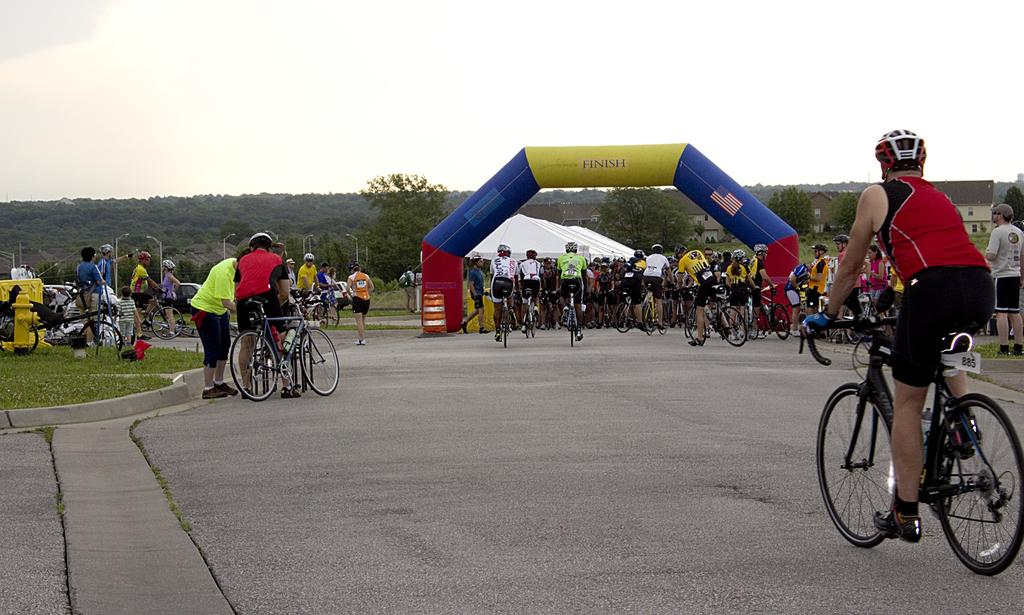What is the main feature of the image? There is a road in the image. What are the people on the road doing? There are people riding cycles on the road. What safety precaution are the cyclists taking? The people are wearing helmets. What architectural feature can be seen in the image? There is an arch in the image. What type of vegetation is visible in the background? There are trees in the background of the image. What part of the natural environment is visible in the image? The sky is visible in the background of the image. How many people are present in the image? There are many people in the image. What type of chair is being used for smoking in the image? There is no chair or smoking activity present in the image. Is there a bathtub visible in the image? There is no bathtub present in the image. 